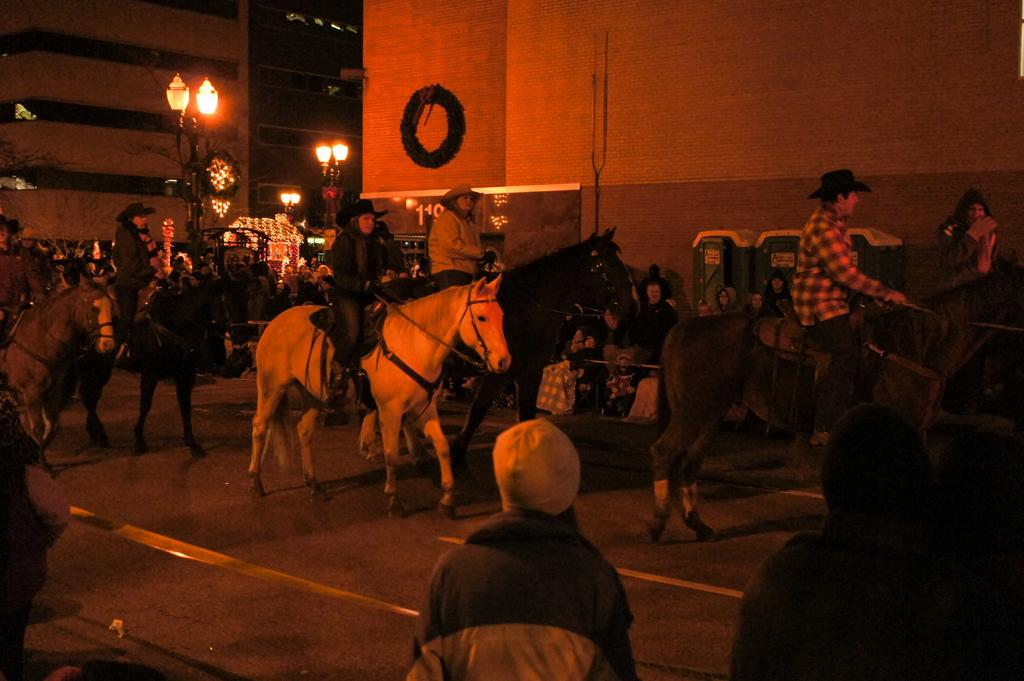What is happening in the image? There is a group of people in the image, and they are riding horses. Where are the horses located? The horses are in the street. What type of fiction is the daughter reading while exchanging horses in the image? There is no daughter or exchange of horses in the image; it features a group of people riding horses in the street. 